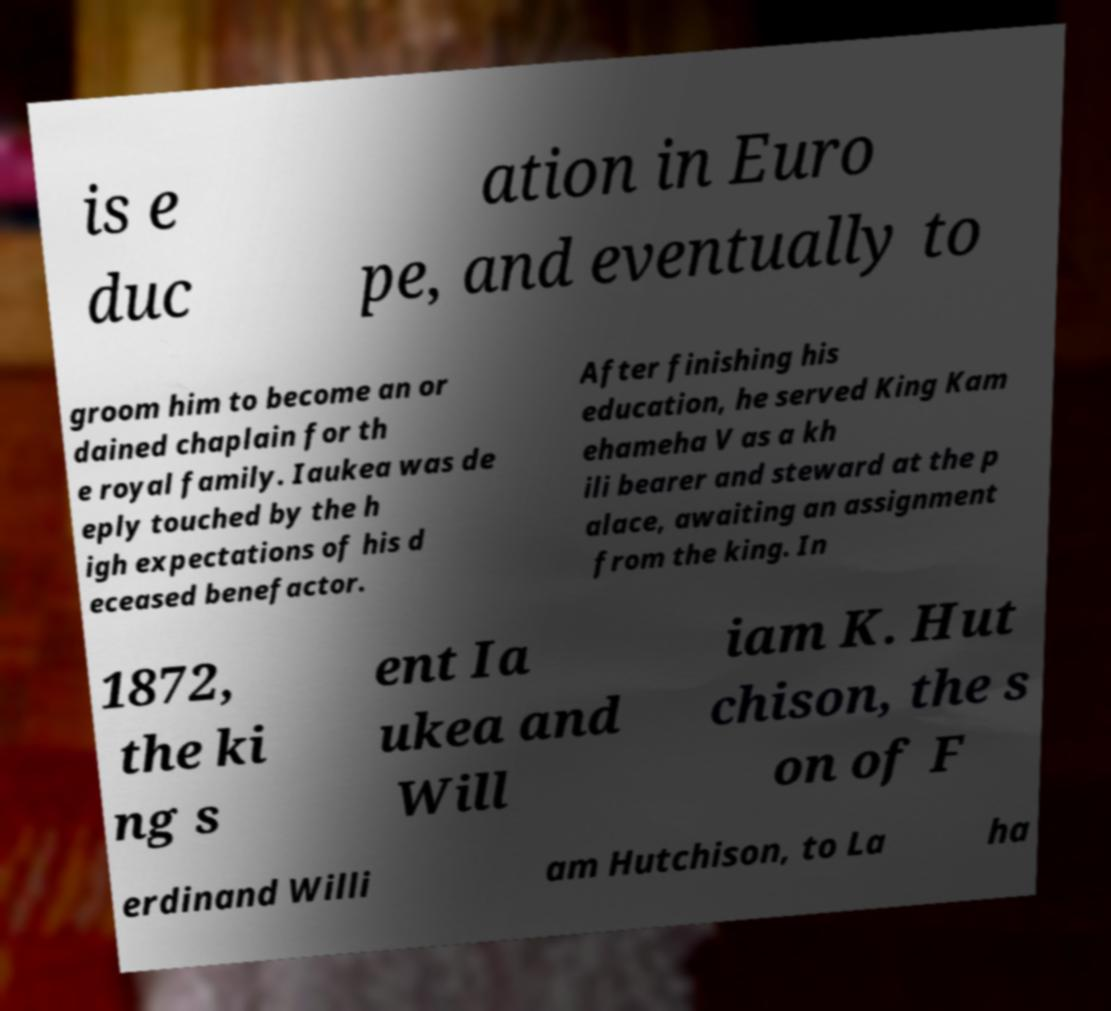Can you read and provide the text displayed in the image?This photo seems to have some interesting text. Can you extract and type it out for me? is e duc ation in Euro pe, and eventually to groom him to become an or dained chaplain for th e royal family. Iaukea was de eply touched by the h igh expectations of his d eceased benefactor. After finishing his education, he served King Kam ehameha V as a kh ili bearer and steward at the p alace, awaiting an assignment from the king. In 1872, the ki ng s ent Ia ukea and Will iam K. Hut chison, the s on of F erdinand Willi am Hutchison, to La ha 